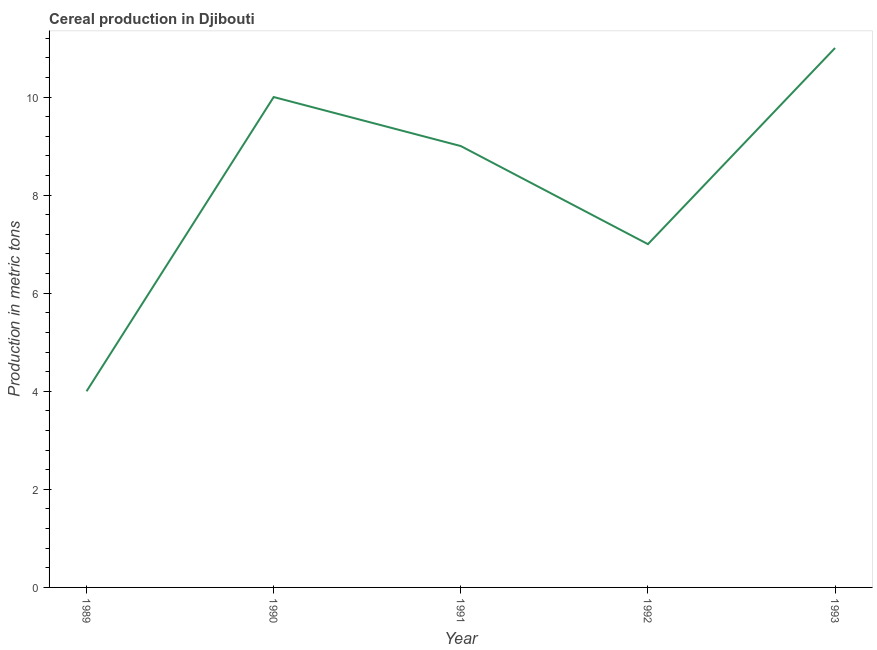What is the cereal production in 1992?
Make the answer very short. 7. Across all years, what is the maximum cereal production?
Ensure brevity in your answer.  11. Across all years, what is the minimum cereal production?
Offer a terse response. 4. In which year was the cereal production minimum?
Your response must be concise. 1989. What is the sum of the cereal production?
Ensure brevity in your answer.  41. What is the difference between the cereal production in 1989 and 1991?
Keep it short and to the point. -5. What is the median cereal production?
Your response must be concise. 9. What is the ratio of the cereal production in 1990 to that in 1993?
Ensure brevity in your answer.  0.91. What is the difference between the highest and the lowest cereal production?
Offer a terse response. 7. In how many years, is the cereal production greater than the average cereal production taken over all years?
Ensure brevity in your answer.  3. How many years are there in the graph?
Offer a very short reply. 5. What is the difference between two consecutive major ticks on the Y-axis?
Your answer should be compact. 2. Are the values on the major ticks of Y-axis written in scientific E-notation?
Provide a short and direct response. No. Does the graph contain any zero values?
Your answer should be very brief. No. What is the title of the graph?
Give a very brief answer. Cereal production in Djibouti. What is the label or title of the X-axis?
Your response must be concise. Year. What is the label or title of the Y-axis?
Keep it short and to the point. Production in metric tons. What is the Production in metric tons in 1990?
Your response must be concise. 10. What is the Production in metric tons in 1992?
Offer a terse response. 7. What is the difference between the Production in metric tons in 1989 and 1990?
Offer a very short reply. -6. What is the difference between the Production in metric tons in 1989 and 1991?
Provide a succinct answer. -5. What is the difference between the Production in metric tons in 1989 and 1992?
Your answer should be very brief. -3. What is the difference between the Production in metric tons in 1990 and 1991?
Offer a terse response. 1. What is the difference between the Production in metric tons in 1990 and 1992?
Provide a short and direct response. 3. What is the difference between the Production in metric tons in 1991 and 1992?
Your answer should be very brief. 2. What is the ratio of the Production in metric tons in 1989 to that in 1991?
Ensure brevity in your answer.  0.44. What is the ratio of the Production in metric tons in 1989 to that in 1992?
Offer a very short reply. 0.57. What is the ratio of the Production in metric tons in 1989 to that in 1993?
Give a very brief answer. 0.36. What is the ratio of the Production in metric tons in 1990 to that in 1991?
Give a very brief answer. 1.11. What is the ratio of the Production in metric tons in 1990 to that in 1992?
Your answer should be very brief. 1.43. What is the ratio of the Production in metric tons in 1990 to that in 1993?
Provide a succinct answer. 0.91. What is the ratio of the Production in metric tons in 1991 to that in 1992?
Offer a terse response. 1.29. What is the ratio of the Production in metric tons in 1991 to that in 1993?
Your response must be concise. 0.82. What is the ratio of the Production in metric tons in 1992 to that in 1993?
Provide a succinct answer. 0.64. 